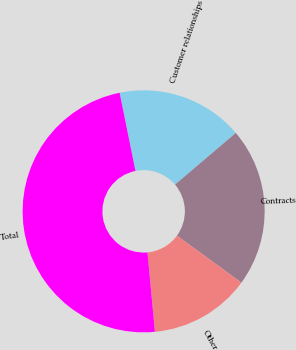Convert chart. <chart><loc_0><loc_0><loc_500><loc_500><pie_chart><fcel>Customer relationships<fcel>Contracts<fcel>Other<fcel>Total<nl><fcel>16.96%<fcel>21.25%<fcel>13.48%<fcel>48.3%<nl></chart> 